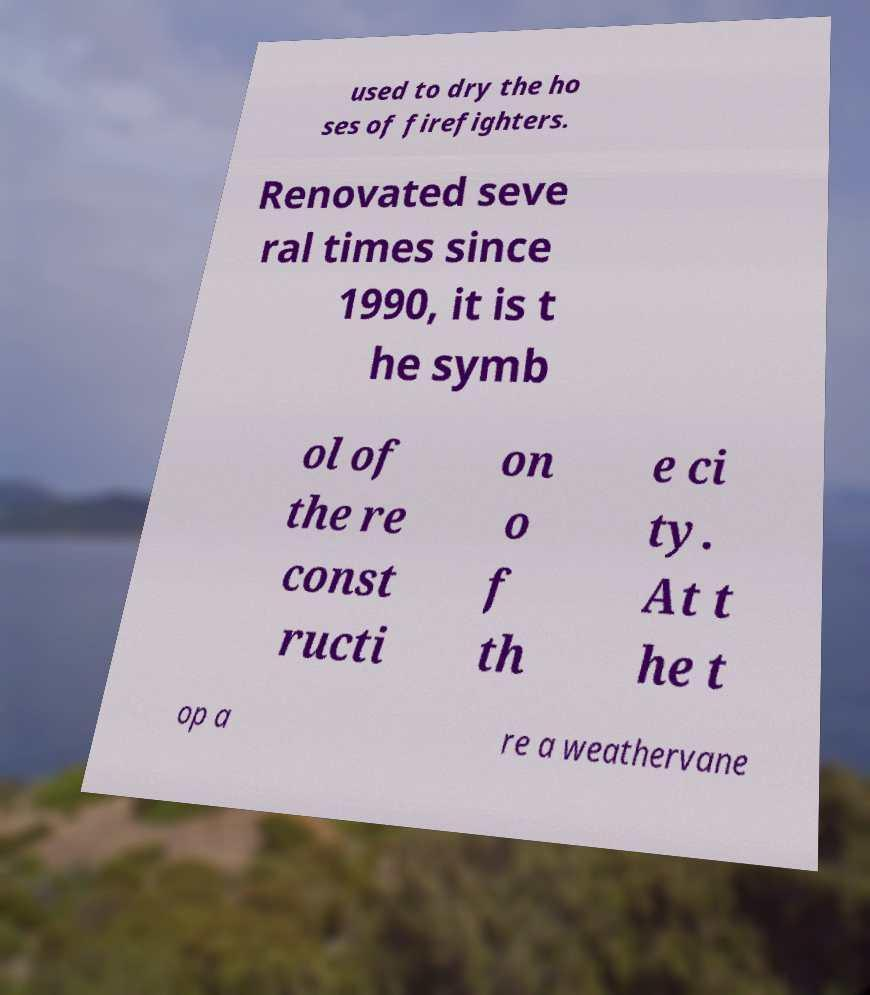I need the written content from this picture converted into text. Can you do that? used to dry the ho ses of firefighters. Renovated seve ral times since 1990, it is t he symb ol of the re const ructi on o f th e ci ty. At t he t op a re a weathervane 